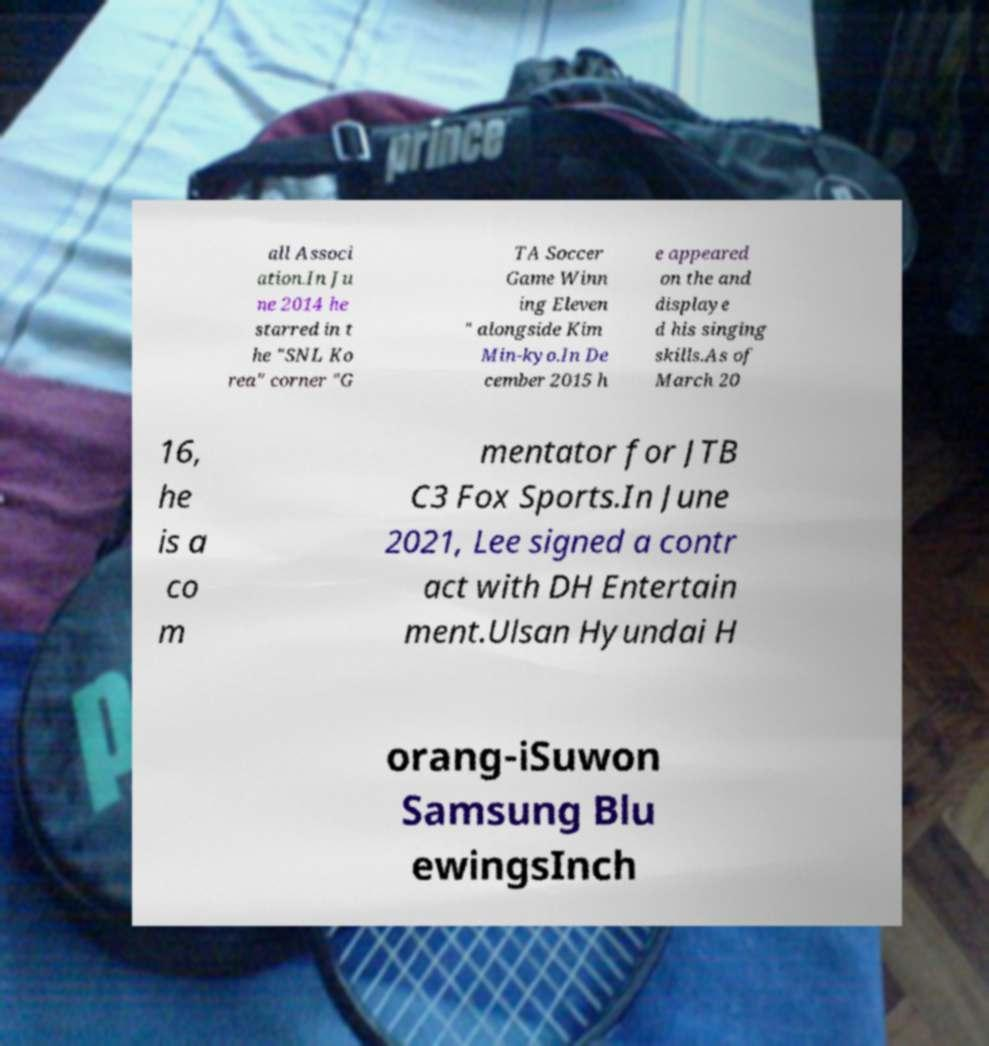Please read and relay the text visible in this image. What does it say? all Associ ation.In Ju ne 2014 he starred in t he "SNL Ko rea" corner "G TA Soccer Game Winn ing Eleven " alongside Kim Min-kyo.In De cember 2015 h e appeared on the and displaye d his singing skills.As of March 20 16, he is a co m mentator for JTB C3 Fox Sports.In June 2021, Lee signed a contr act with DH Entertain ment.Ulsan Hyundai H orang-iSuwon Samsung Blu ewingsInch 